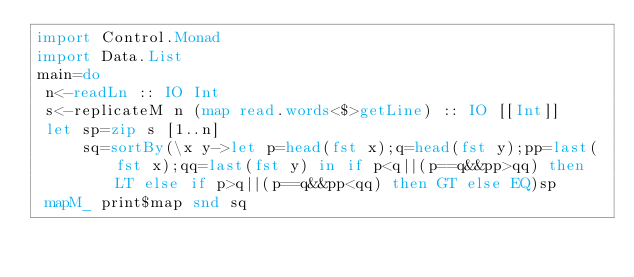Convert code to text. <code><loc_0><loc_0><loc_500><loc_500><_Haskell_>import Control.Monad
import Data.List
main=do
 n<-readLn :: IO Int
 s<-replicateM n (map read.words<$>getLine) :: IO [[Int]]
 let sp=zip s [1..n]
     sq=sortBy(\x y->let p=head(fst x);q=head(fst y);pp=last(fst x);qq=last(fst y) in if p<q||(p==q&&pp>qq) then LT else if p>q||(p==q&&pp<qq) then GT else EQ)sp
 mapM_ print$map snd sq</code> 